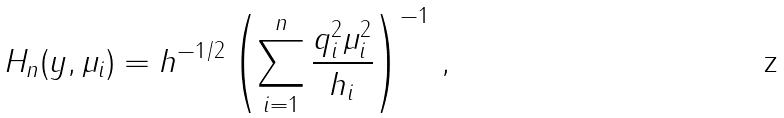Convert formula to latex. <formula><loc_0><loc_0><loc_500><loc_500>H _ { n } ( y , \mu _ { i } ) = h ^ { - 1 / 2 } \left ( \sum _ { i = 1 } ^ { n } \frac { q _ { i } ^ { 2 } \mu _ { i } ^ { 2 } } { h _ { i } } \right ) ^ { - 1 } \, ,</formula> 